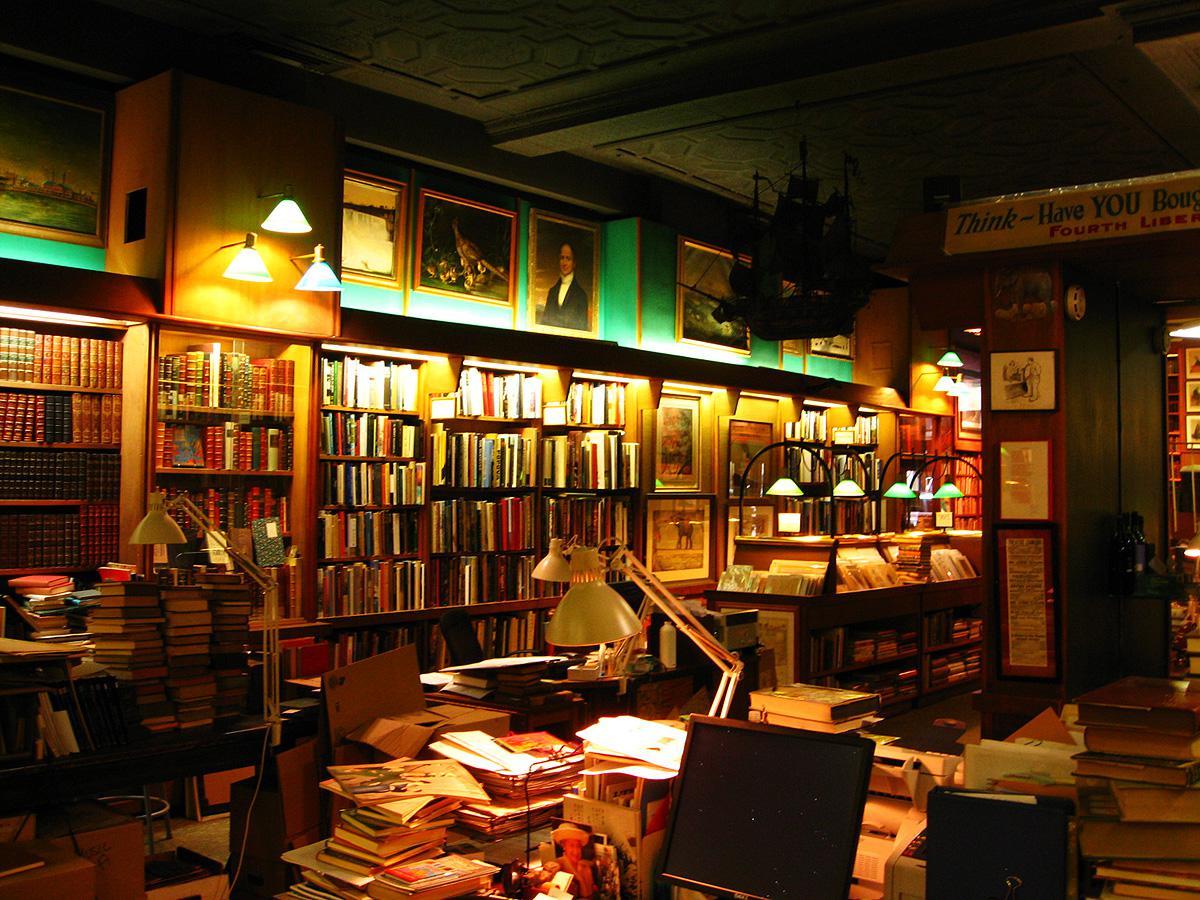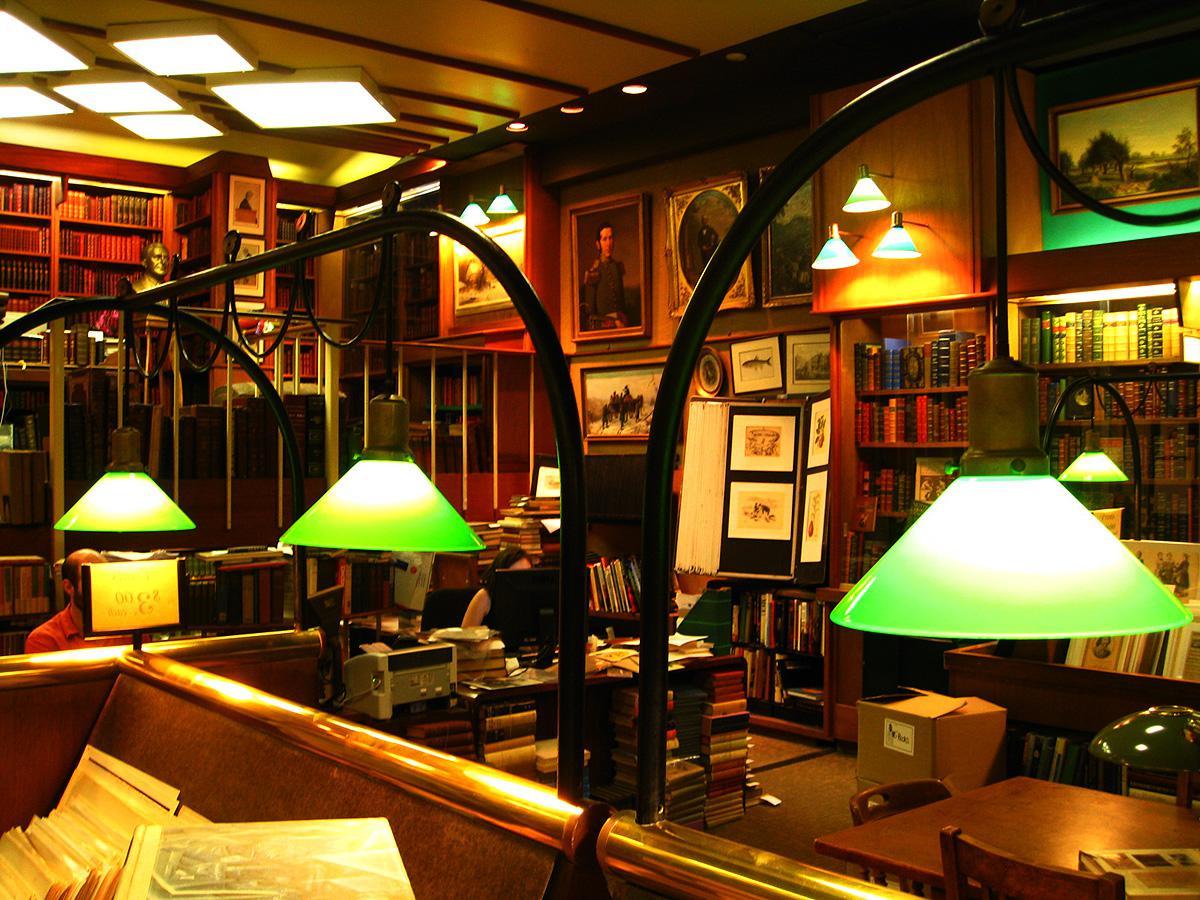The first image is the image on the left, the second image is the image on the right. Considering the images on both sides, is "The right image includes green reading lamps suspended from black arches." valid? Answer yes or no. Yes. 